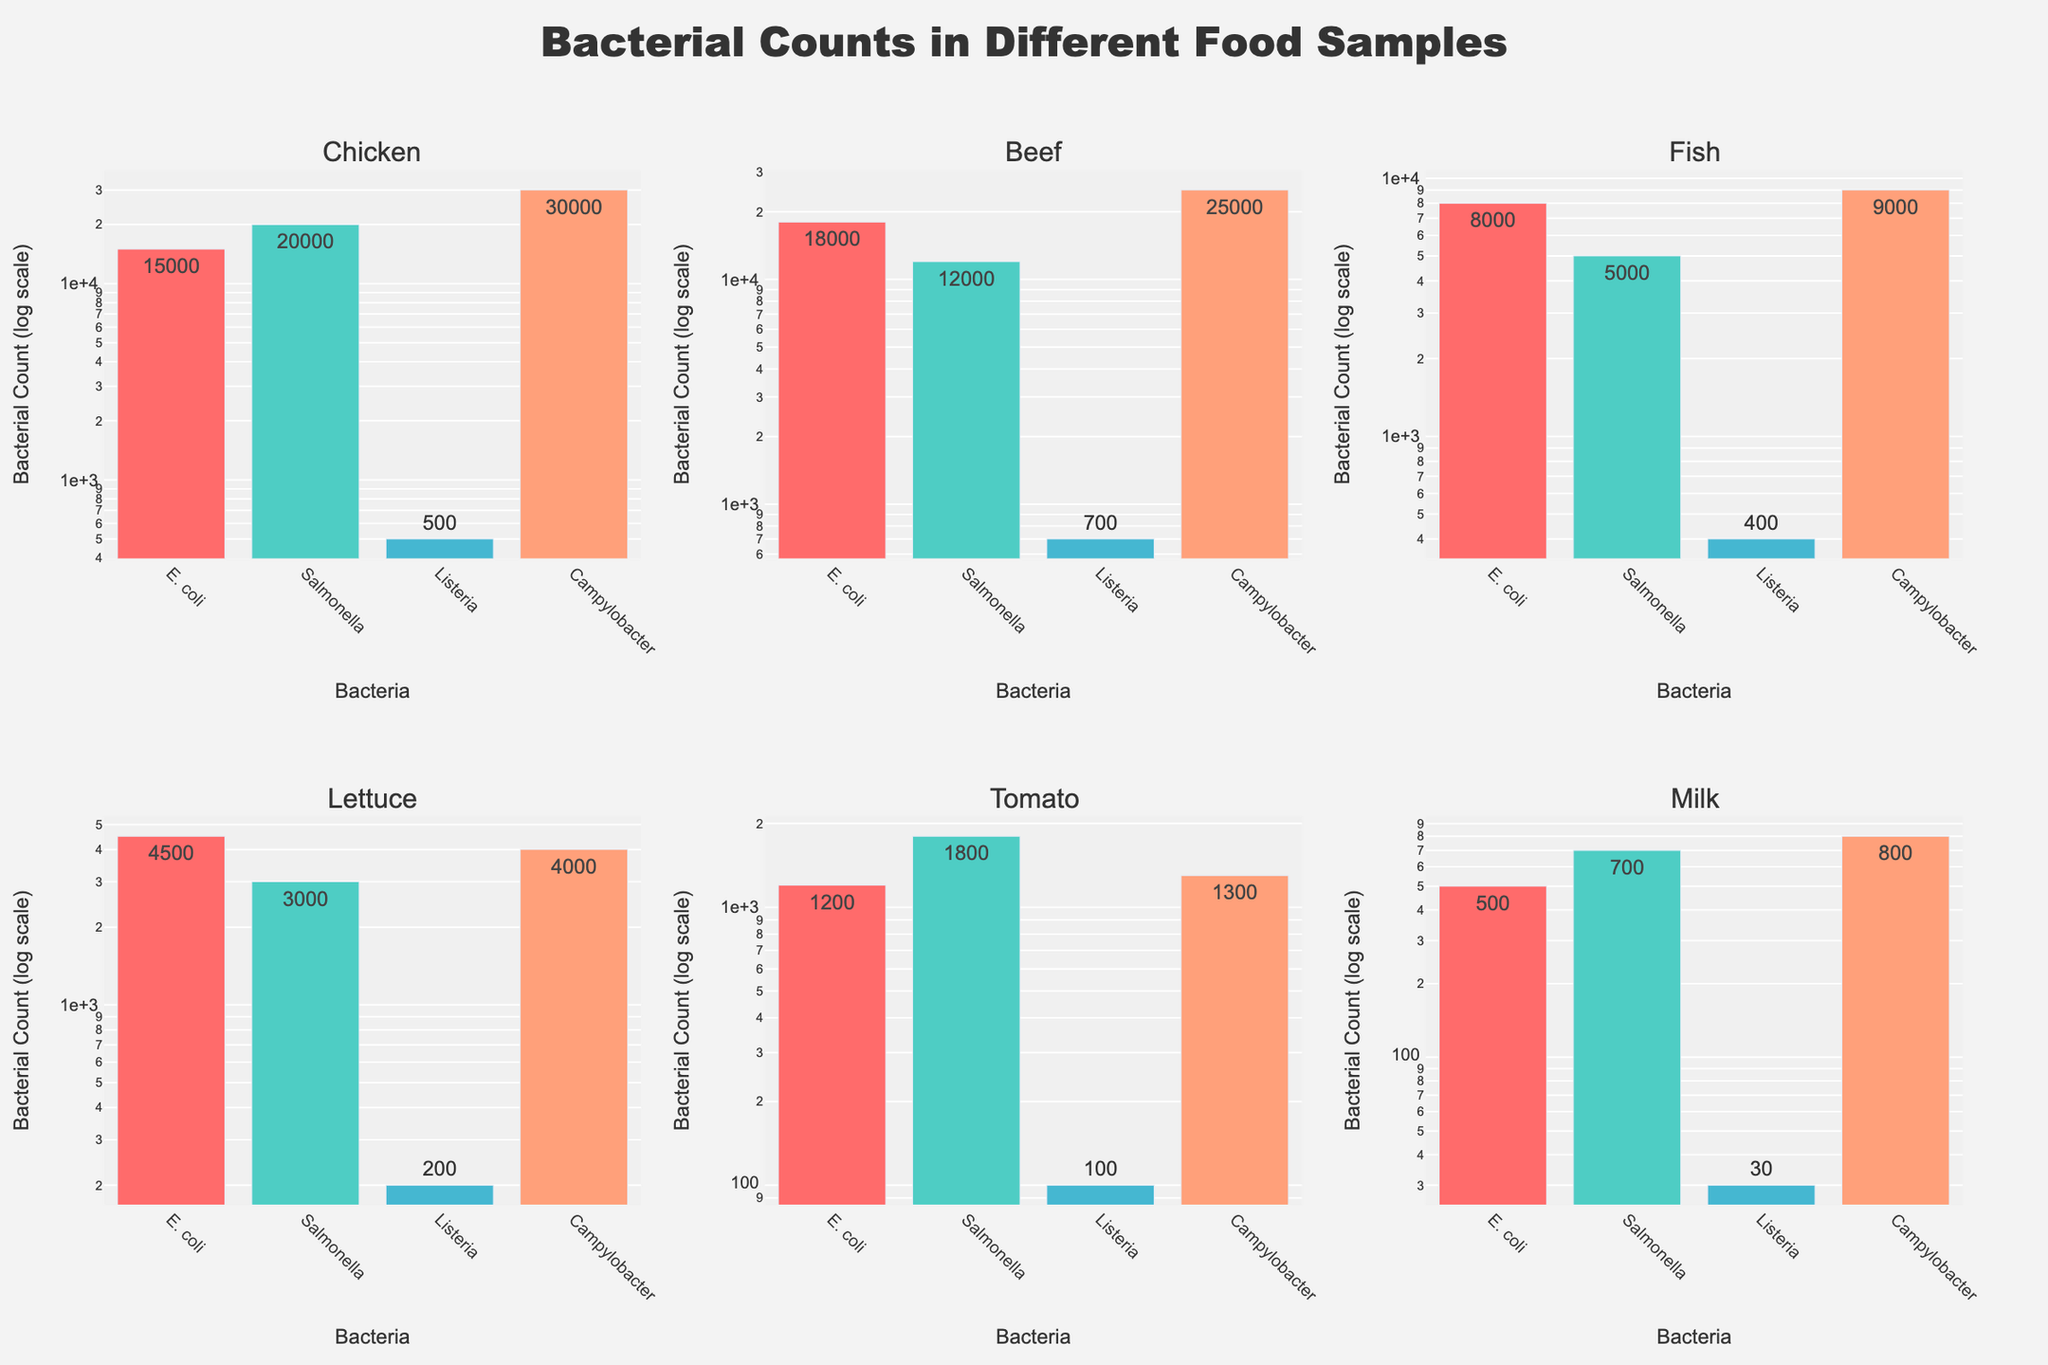What is the title of the plot? The title of the plot is displayed prominently at the top of the figure. It reads "Bacterial Counts in Different Food Samples".
Answer: Bacterial Counts in Different Food Samples Which bacterial type has the highest count in Chicken? Look at the subplot for Chicken and identify the bacterial type with the highest bar. The bar representing Campylobacter is the tallest, indicating it has the highest count.
Answer: Campylobacter What is the count difference between E. coli and Salmonella in Beef? In the Beef subplot, note the counts for E. coli (18,000) and Salmonella (12,000). Subtract the smaller count from the larger one: 18,000 - 12,000 = 6,000.
Answer: 6,000 Which food sample has the lowest count of Listeria? Examine the counts of Listeria in all subplots. The subplot for Milk shows the lowest count of Listeria at 30.
Answer: Milk Compare the count of Campylobacter in Fish and in Tomato. Which one is higher and by how much? Look at the Campylobacter counts in both Fish (9,000) and Tomato (1,300). Subtract the smaller count from the larger one: 9,000 - 1,300 = 7,700. Fish has the higher count.
Answer: Fish, 7,700 In which food sample is the overall bacteria count the most varied? Assess the range of counts within each food sample’s subplot by comparing the highest and lowest values. Chicken has the most varied counts, with values from 500 to 30,000.
Answer: Chicken How many times greater is the count of Campylobacter compared to Listeria in Lettuce? Find the counts for Campylobacter (4,000) and Listeria (200) in the Lettuce subplot. Divide Campylobacter by Listeria: 4,000 / 200 = 20.
Answer: 20 times Looking at the subplots, which bacterial type appears the most frequently, regardless of count? Identify which bacteria type is represented in every subplot. E. coli, Salmonella, Listeria, and Campylobacter all appear in every subplot, so they all appear with equal frequency.
Answer: All types appear equally Between Salmonella and E. coli, which has a higher count across all food samples and by how much? Sum the counts for Salmonella: 20,000 + 12,000 + 5,000 + 3,000 + 1,800 + 700 = 42,500. Sum the counts for E. coli: 15,000 + 18,000 + 8,000 + 4,500 + 1,200 + 500 = 47,200. Subtract the smaller sum from the larger one: 47,200 - 42,500 = 4,700.
Answer: E. coli by 4,700 